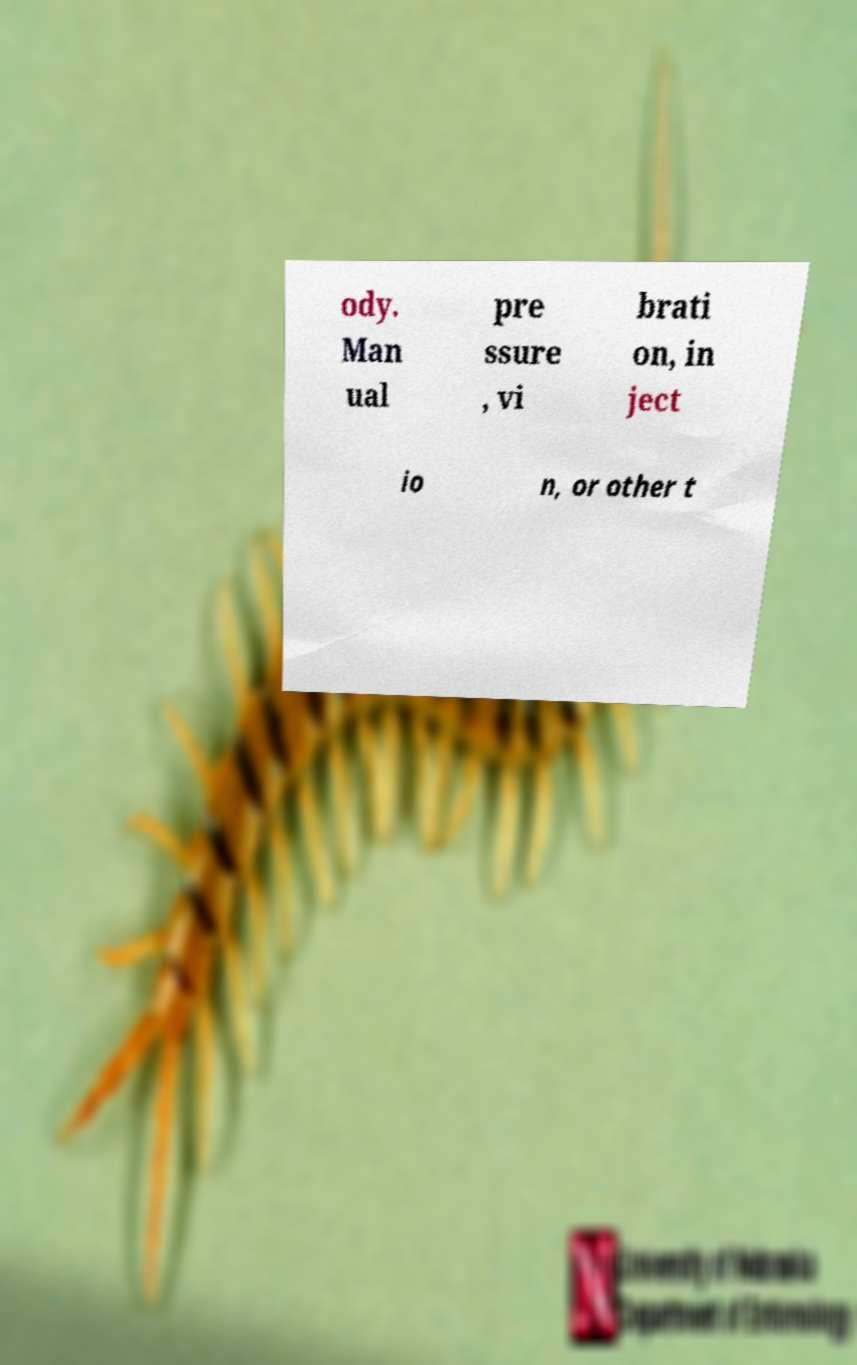Could you extract and type out the text from this image? ody. Man ual pre ssure , vi brati on, in ject io n, or other t 